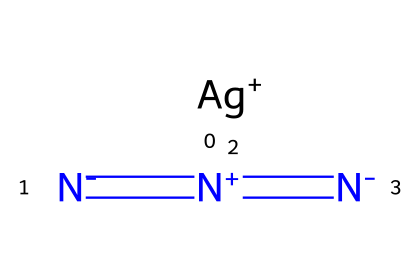What is the total number of nitrogen atoms in the chemical structure? The chemical structure shows three separate nitrogen atoms connected by double bonds. Counting these gives a total of three nitrogen atoms.
Answer: three How many bonds are present between the nitrogen atoms? The chemical structure displays two double bonds between the three nitrogen atoms. Each double bond consists of two bonds, thus 2 bonds (2 double bonds) x 2 = 4.
Answer: four What is the role of silver in this azide compound? In this structure, silver (Ag) has a +1 oxidation state and acts as a cation, stabilizing the overall structure of silver azide by balancing the negative charges of the azide anion.
Answer: cation What is the valence of the central nitrogen atom? In silver azide, the central nitrogen is involved in forming double bonds with the other nitrogen atoms, which is characteristic of a nitrogen atom with a valence of three as it is bonded to multiple atoms.
Answer: three Identify the type of bonding present in this chemical compound. The structure contains both ionic and covalent bonding; the silver cation interacts with the azide anion through ionic interactions, while the nitrogen atoms are connected through covalent bonds.
Answer: ionic and covalent What configuration does silver azide have in terms of molecular shape? Given the presence of the linear arrangement of nitrogen atoms and ionic interactions with silver, the molecular shape has a linear geometry made by the nitrogen atoms.
Answer: linear What specific type of chemical is represented by the azide group? The azide group is classically recognized as a functional group consisting of three nitrogen atoms, characterized by its -N3 structure, which is unique to azides.
Answer: azide 